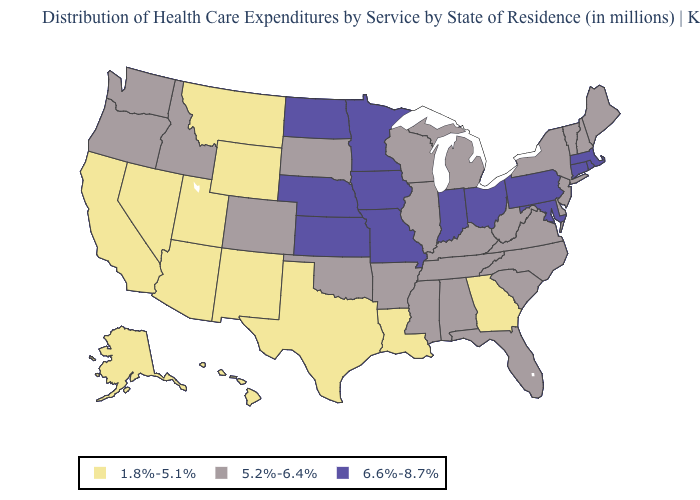What is the value of Wisconsin?
Give a very brief answer. 5.2%-6.4%. What is the value of Tennessee?
Write a very short answer. 5.2%-6.4%. What is the value of Georgia?
Answer briefly. 1.8%-5.1%. What is the lowest value in states that border New Mexico?
Write a very short answer. 1.8%-5.1%. Does the map have missing data?
Give a very brief answer. No. What is the lowest value in the USA?
Answer briefly. 1.8%-5.1%. Does Pennsylvania have the highest value in the USA?
Give a very brief answer. Yes. What is the highest value in states that border Idaho?
Write a very short answer. 5.2%-6.4%. What is the value of New Jersey?
Quick response, please. 5.2%-6.4%. What is the value of Alaska?
Answer briefly. 1.8%-5.1%. Does Louisiana have the lowest value in the USA?
Concise answer only. Yes. What is the value of Nevada?
Answer briefly. 1.8%-5.1%. What is the highest value in the South ?
Be succinct. 6.6%-8.7%. What is the lowest value in the MidWest?
Short answer required. 5.2%-6.4%. Is the legend a continuous bar?
Be succinct. No. 